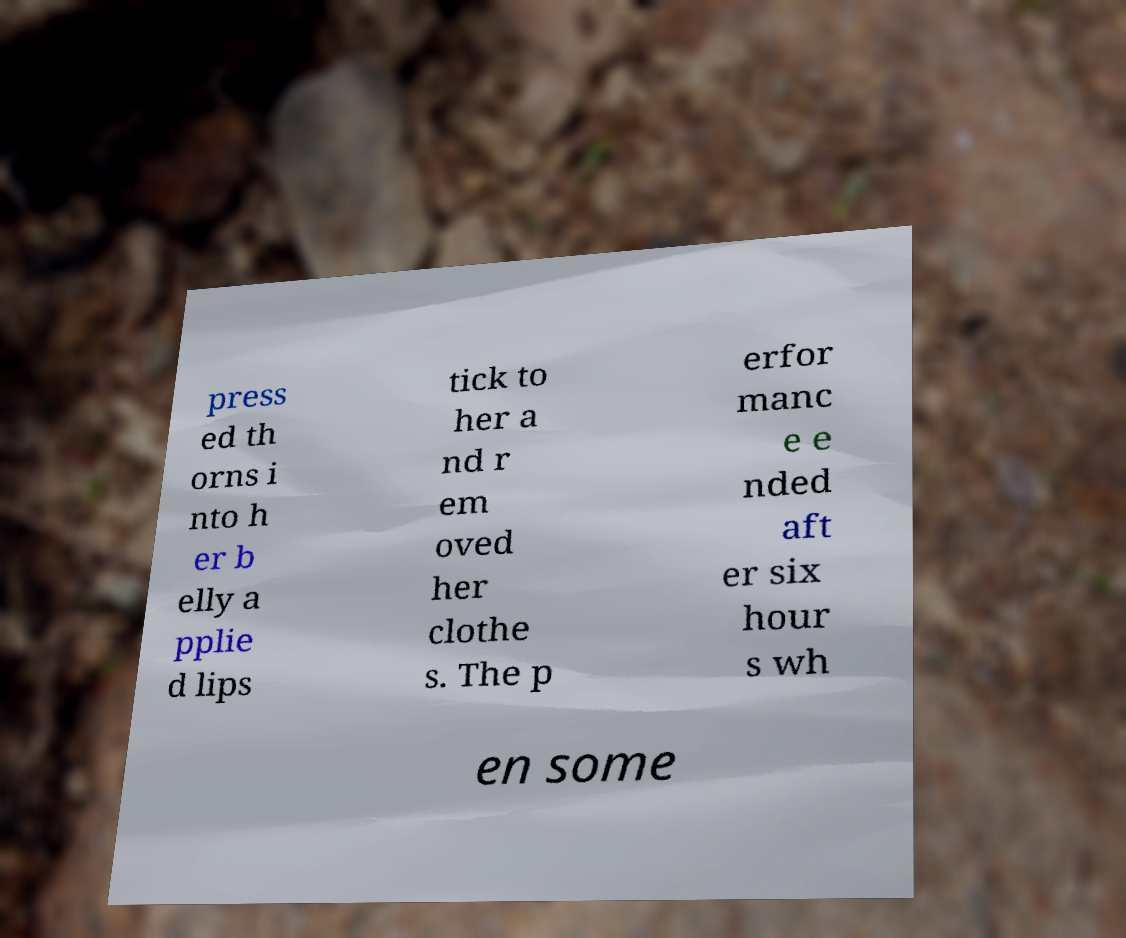Could you extract and type out the text from this image? press ed th orns i nto h er b elly a pplie d lips tick to her a nd r em oved her clothe s. The p erfor manc e e nded aft er six hour s wh en some 